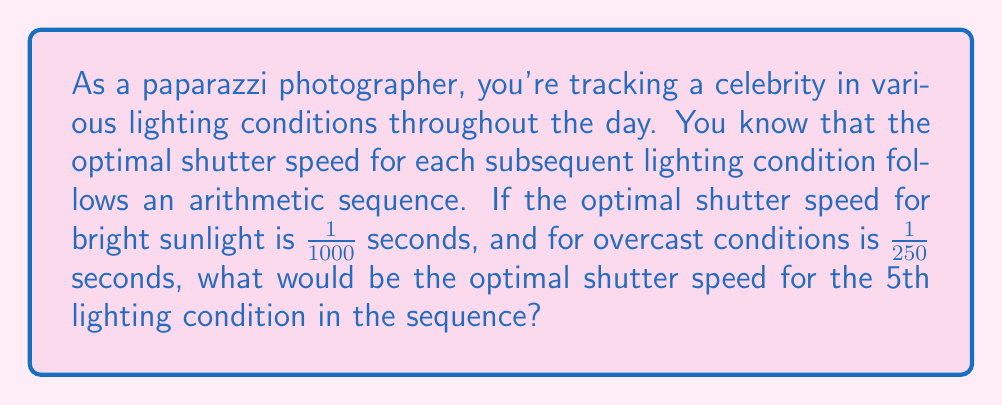What is the answer to this math problem? Let's approach this step-by-step:

1) First, we need to identify the arithmetic sequence. We have two known values:
   $a_1 = \frac{1}{1000}$ (bright sunlight)
   $a_2 = \frac{1}{250}$ (overcast)

2) In an arithmetic sequence, the difference between any two consecutive terms is constant. Let's call this common difference $d$. We can find $d$ using:

   $d = a_2 - a_1 = \frac{1}{250} - \frac{1}{1000} = \frac{4}{1000} - \frac{1}{1000} = \frac{3}{1000}$

3) Now that we have the common difference, we can use the arithmetic sequence formula:

   $a_n = a_1 + (n-1)d$

   Where $a_n$ is the nth term, $a_1$ is the first term, $n$ is the position of the term we're looking for, and $d$ is the common difference.

4) We're looking for the 5th term, so $n = 5$:

   $a_5 = \frac{1}{1000} + (5-1) \cdot \frac{3}{1000}$

5) Simplify:
   $a_5 = \frac{1}{1000} + \frac{12}{1000} = \frac{13}{1000}$

6) To express this as a fraction with 1 in the numerator:

   $a_5 = \frac{1}{\frac{1000}{13}} \approx \frac{1}{76.92}$

Therefore, the optimal shutter speed for the 5th lighting condition would be approximately 1/77 seconds.
Answer: $\frac{1}{77}$ seconds 